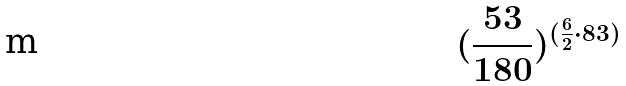Convert formula to latex. <formula><loc_0><loc_0><loc_500><loc_500>( \frac { 5 3 } { 1 8 0 } ) ^ { ( \frac { 6 } { 2 } \cdot 8 3 ) }</formula> 